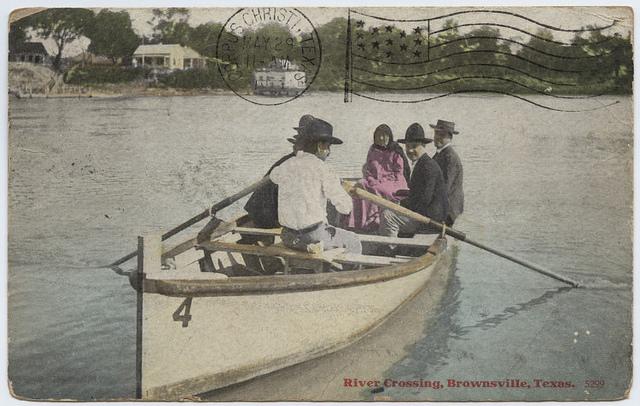Are all of the people men?
Give a very brief answer. No. What is the number on the boat?
Keep it brief. 4. Is this a postcard?
Give a very brief answer. Yes. 